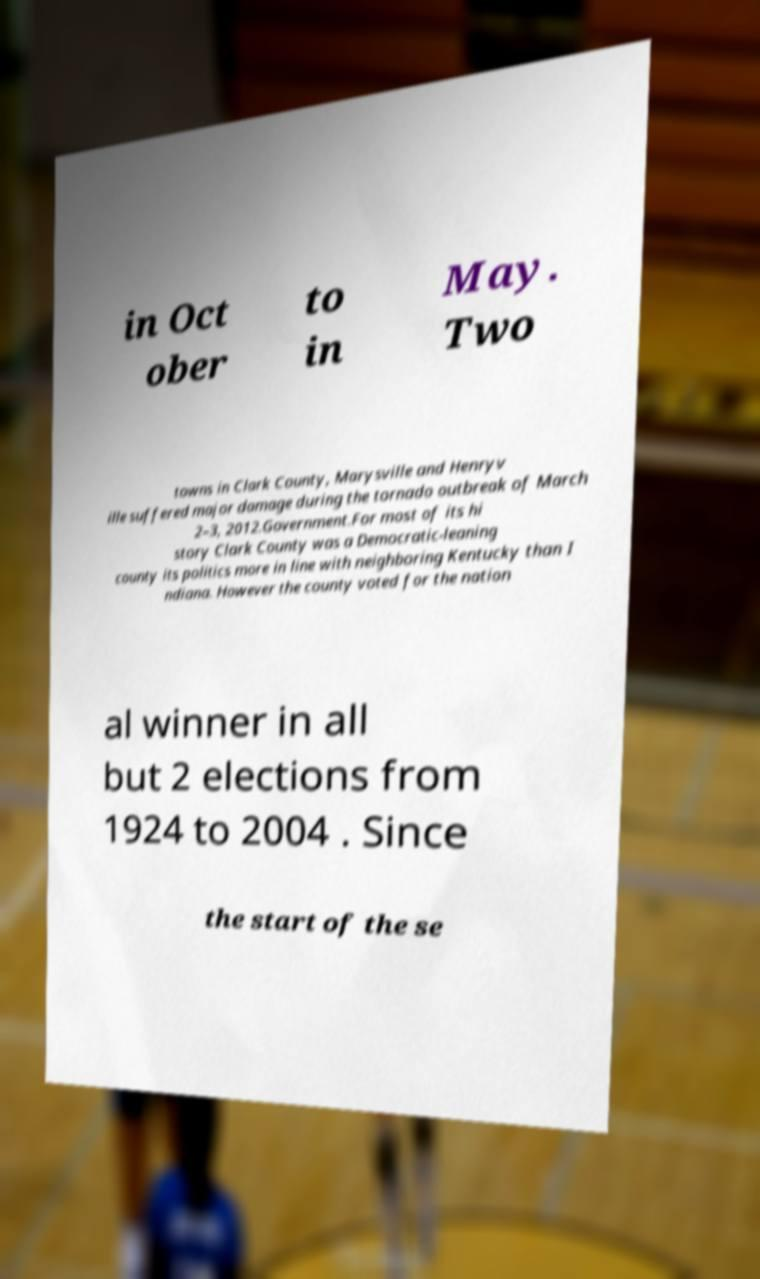I need the written content from this picture converted into text. Can you do that? in Oct ober to in May. Two towns in Clark County, Marysville and Henryv ille suffered major damage during the tornado outbreak of March 2–3, 2012.Government.For most of its hi story Clark County was a Democratic-leaning county its politics more in line with neighboring Kentucky than I ndiana. However the county voted for the nation al winner in all but 2 elections from 1924 to 2004 . Since the start of the se 